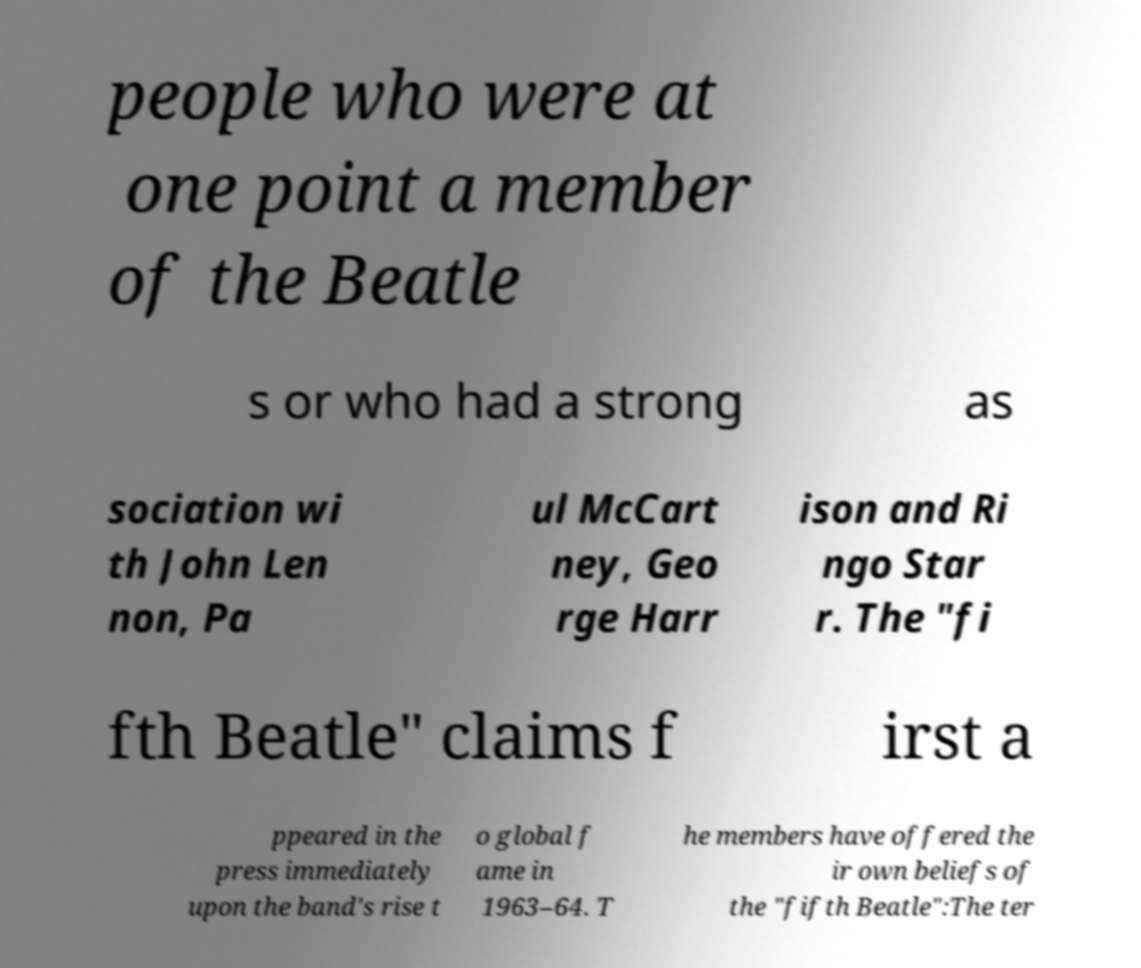I need the written content from this picture converted into text. Can you do that? people who were at one point a member of the Beatle s or who had a strong as sociation wi th John Len non, Pa ul McCart ney, Geo rge Harr ison and Ri ngo Star r. The "fi fth Beatle" claims f irst a ppeared in the press immediately upon the band's rise t o global f ame in 1963–64. T he members have offered the ir own beliefs of the "fifth Beatle":The ter 